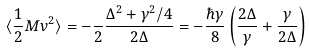Convert formula to latex. <formula><loc_0><loc_0><loc_500><loc_500>\langle \frac { 1 } { 2 } M v ^ { 2 } \rangle = - \frac { } { 2 } \frac { \Delta ^ { 2 } + \gamma ^ { 2 } / 4 } { 2 \Delta } = - \frac { \hbar { \gamma } } { 8 } \left ( \frac { 2 \Delta } { \gamma } + \frac { \gamma } { 2 \Delta } \right )</formula> 